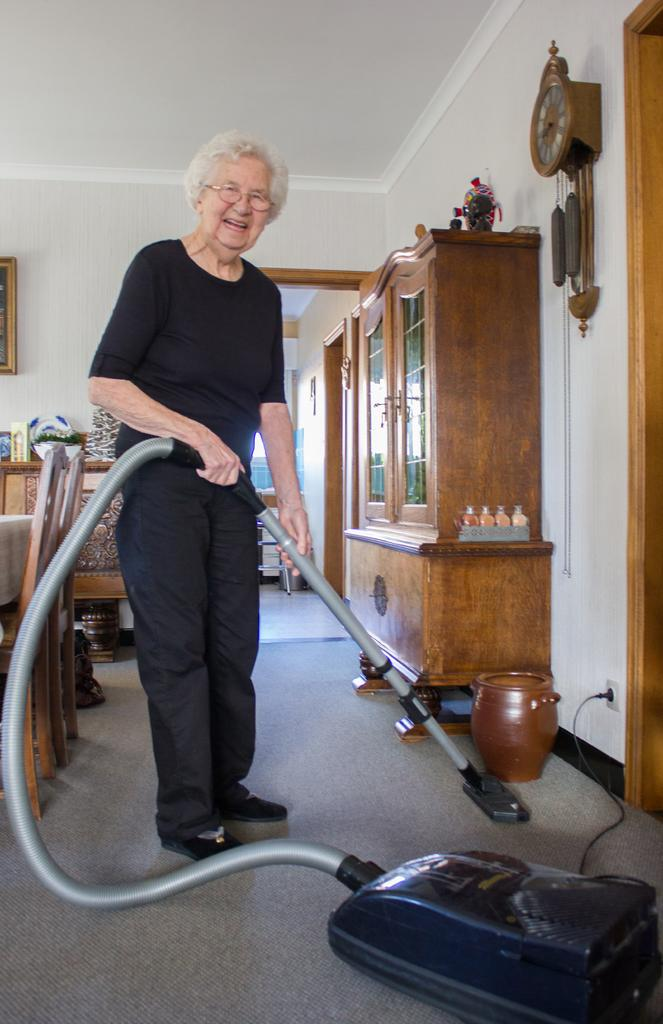Who is the main subject in the image? There is a woman in the image. What is the woman doing in the image? The woman is standing and holding a vacuum cleaner, and she is cleaning the house. What type of furniture can be seen in the image? There are chairs visible in the image. Where is the cupboard located in the image? The cupboard is on the right side of the image. What statement does the woman make while cleaning the house in the image? There is no dialogue or statement visible in the image; it only shows the woman cleaning the house with a vacuum cleaner. 